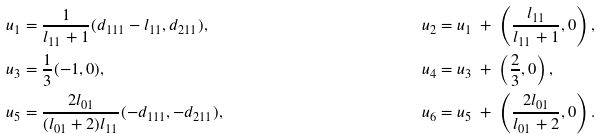<formula> <loc_0><loc_0><loc_500><loc_500>u _ { 1 } = & \ \frac { 1 } { l _ { 1 1 } + 1 } ( d _ { 1 1 1 } - l _ { 1 1 } , d _ { 2 1 1 } ) , & u _ { 2 } = & \ u _ { 1 } \ + \ \left ( \frac { l _ { 1 1 } } { l _ { 1 1 } + 1 } , 0 \right ) , \\ u _ { 3 } = & \ \frac { 1 } { 3 } ( - 1 , 0 ) , & u _ { 4 } = & \ u _ { 3 } \ + \ \left ( \frac { 2 } { 3 } , 0 \right ) , \\ u _ { 5 } = & \ \frac { 2 l _ { 0 1 } } { ( l _ { 0 1 } + 2 ) l _ { 1 1 } } ( - d _ { 1 1 1 } , - d _ { 2 1 1 } ) , & u _ { 6 } = & \ u _ { 5 } \ + \ \left ( \frac { 2 l _ { 0 1 } } { l _ { 0 1 } + 2 } , 0 \right ) .</formula> 